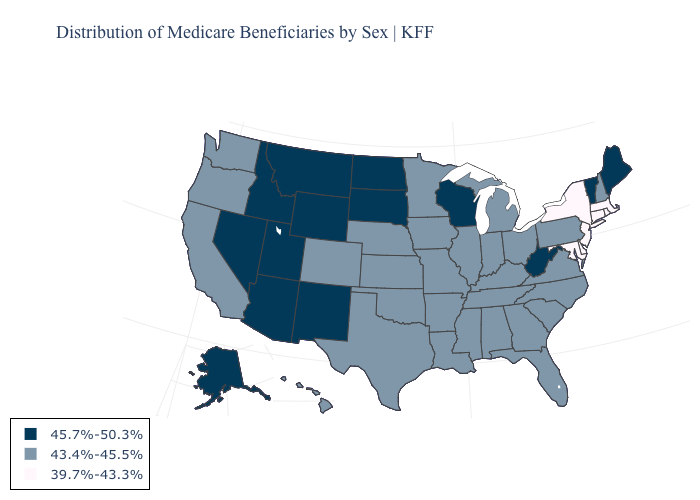Name the states that have a value in the range 45.7%-50.3%?
Write a very short answer. Alaska, Arizona, Idaho, Maine, Montana, Nevada, New Mexico, North Dakota, South Dakota, Utah, Vermont, West Virginia, Wisconsin, Wyoming. Does Pennsylvania have a higher value than New Jersey?
Quick response, please. Yes. Name the states that have a value in the range 43.4%-45.5%?
Give a very brief answer. Alabama, Arkansas, California, Colorado, Florida, Georgia, Hawaii, Illinois, Indiana, Iowa, Kansas, Kentucky, Louisiana, Michigan, Minnesota, Mississippi, Missouri, Nebraska, New Hampshire, North Carolina, Ohio, Oklahoma, Oregon, Pennsylvania, South Carolina, Tennessee, Texas, Virginia, Washington. Name the states that have a value in the range 43.4%-45.5%?
Give a very brief answer. Alabama, Arkansas, California, Colorado, Florida, Georgia, Hawaii, Illinois, Indiana, Iowa, Kansas, Kentucky, Louisiana, Michigan, Minnesota, Mississippi, Missouri, Nebraska, New Hampshire, North Carolina, Ohio, Oklahoma, Oregon, Pennsylvania, South Carolina, Tennessee, Texas, Virginia, Washington. Does New York have the highest value in the USA?
Answer briefly. No. Which states hav the highest value in the MidWest?
Keep it brief. North Dakota, South Dakota, Wisconsin. Does Indiana have the highest value in the USA?
Quick response, please. No. Name the states that have a value in the range 45.7%-50.3%?
Be succinct. Alaska, Arizona, Idaho, Maine, Montana, Nevada, New Mexico, North Dakota, South Dakota, Utah, Vermont, West Virginia, Wisconsin, Wyoming. Name the states that have a value in the range 39.7%-43.3%?
Keep it brief. Connecticut, Delaware, Maryland, Massachusetts, New Jersey, New York, Rhode Island. What is the value of Maine?
Be succinct. 45.7%-50.3%. Does South Dakota have the lowest value in the MidWest?
Give a very brief answer. No. Among the states that border Pennsylvania , which have the highest value?
Answer briefly. West Virginia. Which states have the highest value in the USA?
Write a very short answer. Alaska, Arizona, Idaho, Maine, Montana, Nevada, New Mexico, North Dakota, South Dakota, Utah, Vermont, West Virginia, Wisconsin, Wyoming. Among the states that border Delaware , which have the highest value?
Be succinct. Pennsylvania. Name the states that have a value in the range 45.7%-50.3%?
Concise answer only. Alaska, Arizona, Idaho, Maine, Montana, Nevada, New Mexico, North Dakota, South Dakota, Utah, Vermont, West Virginia, Wisconsin, Wyoming. 